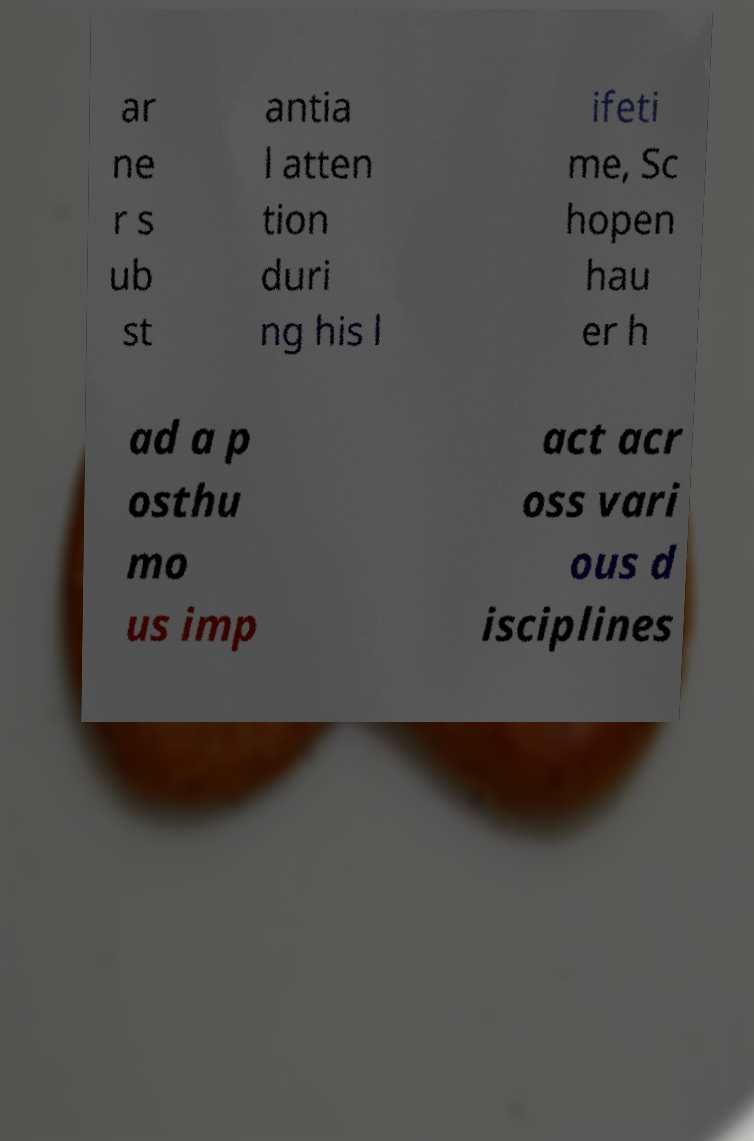Please identify and transcribe the text found in this image. ar ne r s ub st antia l atten tion duri ng his l ifeti me, Sc hopen hau er h ad a p osthu mo us imp act acr oss vari ous d isciplines 